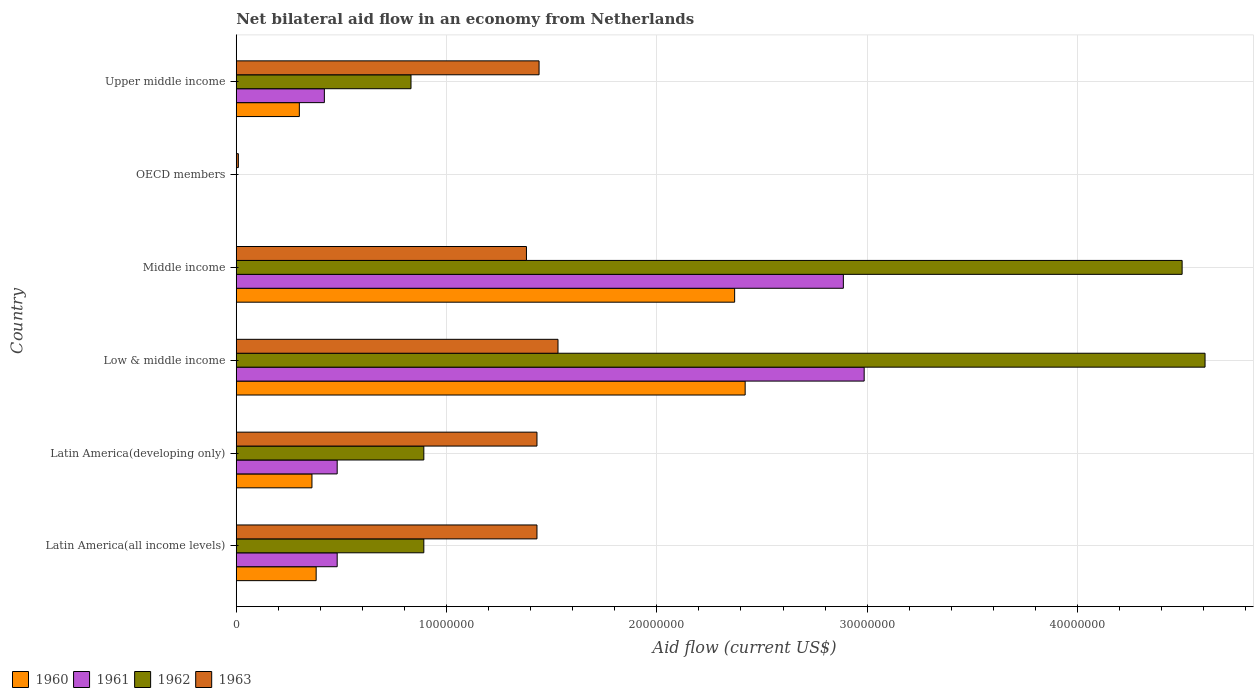How many bars are there on the 2nd tick from the bottom?
Your response must be concise. 4. What is the label of the 3rd group of bars from the top?
Offer a very short reply. Middle income. In how many cases, is the number of bars for a given country not equal to the number of legend labels?
Your response must be concise. 1. What is the net bilateral aid flow in 1963 in OECD members?
Keep it short and to the point. 1.00e+05. Across all countries, what is the maximum net bilateral aid flow in 1963?
Make the answer very short. 1.53e+07. In which country was the net bilateral aid flow in 1960 maximum?
Give a very brief answer. Low & middle income. What is the total net bilateral aid flow in 1960 in the graph?
Offer a terse response. 5.83e+07. What is the difference between the net bilateral aid flow in 1963 in Low & middle income and that in Middle income?
Provide a short and direct response. 1.50e+06. What is the difference between the net bilateral aid flow in 1960 in OECD members and the net bilateral aid flow in 1961 in Middle income?
Provide a succinct answer. -2.89e+07. What is the average net bilateral aid flow in 1963 per country?
Keep it short and to the point. 1.20e+07. What is the difference between the net bilateral aid flow in 1961 and net bilateral aid flow in 1960 in Latin America(developing only)?
Make the answer very short. 1.20e+06. In how many countries, is the net bilateral aid flow in 1961 greater than 42000000 US$?
Your answer should be very brief. 0. What is the ratio of the net bilateral aid flow in 1960 in Low & middle income to that in Middle income?
Make the answer very short. 1.02. Is the net bilateral aid flow in 1963 in Latin America(all income levels) less than that in Upper middle income?
Offer a very short reply. Yes. Is the difference between the net bilateral aid flow in 1961 in Middle income and Upper middle income greater than the difference between the net bilateral aid flow in 1960 in Middle income and Upper middle income?
Offer a terse response. Yes. What is the difference between the highest and the lowest net bilateral aid flow in 1962?
Give a very brief answer. 4.61e+07. Is the sum of the net bilateral aid flow in 1960 in Low & middle income and Upper middle income greater than the maximum net bilateral aid flow in 1963 across all countries?
Provide a short and direct response. Yes. Is it the case that in every country, the sum of the net bilateral aid flow in 1961 and net bilateral aid flow in 1963 is greater than the sum of net bilateral aid flow in 1962 and net bilateral aid flow in 1960?
Keep it short and to the point. No. Is it the case that in every country, the sum of the net bilateral aid flow in 1960 and net bilateral aid flow in 1963 is greater than the net bilateral aid flow in 1961?
Keep it short and to the point. Yes. What is the difference between two consecutive major ticks on the X-axis?
Your answer should be compact. 1.00e+07. Does the graph contain grids?
Keep it short and to the point. Yes. Where does the legend appear in the graph?
Provide a succinct answer. Bottom left. What is the title of the graph?
Your answer should be compact. Net bilateral aid flow in an economy from Netherlands. Does "1968" appear as one of the legend labels in the graph?
Offer a very short reply. No. What is the label or title of the X-axis?
Provide a short and direct response. Aid flow (current US$). What is the Aid flow (current US$) of 1960 in Latin America(all income levels)?
Ensure brevity in your answer.  3.80e+06. What is the Aid flow (current US$) in 1961 in Latin America(all income levels)?
Offer a very short reply. 4.80e+06. What is the Aid flow (current US$) in 1962 in Latin America(all income levels)?
Offer a very short reply. 8.92e+06. What is the Aid flow (current US$) in 1963 in Latin America(all income levels)?
Your answer should be compact. 1.43e+07. What is the Aid flow (current US$) in 1960 in Latin America(developing only)?
Keep it short and to the point. 3.60e+06. What is the Aid flow (current US$) of 1961 in Latin America(developing only)?
Provide a succinct answer. 4.80e+06. What is the Aid flow (current US$) of 1962 in Latin America(developing only)?
Offer a terse response. 8.92e+06. What is the Aid flow (current US$) of 1963 in Latin America(developing only)?
Provide a short and direct response. 1.43e+07. What is the Aid flow (current US$) of 1960 in Low & middle income?
Provide a succinct answer. 2.42e+07. What is the Aid flow (current US$) of 1961 in Low & middle income?
Make the answer very short. 2.99e+07. What is the Aid flow (current US$) of 1962 in Low & middle income?
Your answer should be very brief. 4.61e+07. What is the Aid flow (current US$) in 1963 in Low & middle income?
Your response must be concise. 1.53e+07. What is the Aid flow (current US$) in 1960 in Middle income?
Give a very brief answer. 2.37e+07. What is the Aid flow (current US$) of 1961 in Middle income?
Give a very brief answer. 2.89e+07. What is the Aid flow (current US$) in 1962 in Middle income?
Offer a very short reply. 4.50e+07. What is the Aid flow (current US$) of 1963 in Middle income?
Offer a very short reply. 1.38e+07. What is the Aid flow (current US$) of 1960 in OECD members?
Ensure brevity in your answer.  0. What is the Aid flow (current US$) in 1961 in OECD members?
Your answer should be very brief. 0. What is the Aid flow (current US$) of 1960 in Upper middle income?
Provide a succinct answer. 3.00e+06. What is the Aid flow (current US$) in 1961 in Upper middle income?
Your response must be concise. 4.19e+06. What is the Aid flow (current US$) of 1962 in Upper middle income?
Keep it short and to the point. 8.31e+06. What is the Aid flow (current US$) of 1963 in Upper middle income?
Make the answer very short. 1.44e+07. Across all countries, what is the maximum Aid flow (current US$) of 1960?
Offer a terse response. 2.42e+07. Across all countries, what is the maximum Aid flow (current US$) of 1961?
Your response must be concise. 2.99e+07. Across all countries, what is the maximum Aid flow (current US$) in 1962?
Keep it short and to the point. 4.61e+07. Across all countries, what is the maximum Aid flow (current US$) of 1963?
Your answer should be very brief. 1.53e+07. Across all countries, what is the minimum Aid flow (current US$) of 1962?
Your answer should be very brief. 0. What is the total Aid flow (current US$) in 1960 in the graph?
Offer a terse response. 5.83e+07. What is the total Aid flow (current US$) of 1961 in the graph?
Your answer should be compact. 7.25e+07. What is the total Aid flow (current US$) in 1962 in the graph?
Your answer should be compact. 1.17e+08. What is the total Aid flow (current US$) of 1963 in the graph?
Ensure brevity in your answer.  7.22e+07. What is the difference between the Aid flow (current US$) in 1962 in Latin America(all income levels) and that in Latin America(developing only)?
Give a very brief answer. 0. What is the difference between the Aid flow (current US$) of 1963 in Latin America(all income levels) and that in Latin America(developing only)?
Keep it short and to the point. 0. What is the difference between the Aid flow (current US$) in 1960 in Latin America(all income levels) and that in Low & middle income?
Offer a terse response. -2.04e+07. What is the difference between the Aid flow (current US$) of 1961 in Latin America(all income levels) and that in Low & middle income?
Make the answer very short. -2.51e+07. What is the difference between the Aid flow (current US$) in 1962 in Latin America(all income levels) and that in Low & middle income?
Offer a very short reply. -3.72e+07. What is the difference between the Aid flow (current US$) of 1960 in Latin America(all income levels) and that in Middle income?
Keep it short and to the point. -1.99e+07. What is the difference between the Aid flow (current US$) of 1961 in Latin America(all income levels) and that in Middle income?
Provide a short and direct response. -2.41e+07. What is the difference between the Aid flow (current US$) of 1962 in Latin America(all income levels) and that in Middle income?
Provide a succinct answer. -3.61e+07. What is the difference between the Aid flow (current US$) in 1963 in Latin America(all income levels) and that in OECD members?
Offer a terse response. 1.42e+07. What is the difference between the Aid flow (current US$) of 1960 in Latin America(all income levels) and that in Upper middle income?
Your response must be concise. 8.00e+05. What is the difference between the Aid flow (current US$) of 1961 in Latin America(all income levels) and that in Upper middle income?
Give a very brief answer. 6.10e+05. What is the difference between the Aid flow (current US$) of 1962 in Latin America(all income levels) and that in Upper middle income?
Your response must be concise. 6.10e+05. What is the difference between the Aid flow (current US$) in 1960 in Latin America(developing only) and that in Low & middle income?
Keep it short and to the point. -2.06e+07. What is the difference between the Aid flow (current US$) in 1961 in Latin America(developing only) and that in Low & middle income?
Provide a succinct answer. -2.51e+07. What is the difference between the Aid flow (current US$) in 1962 in Latin America(developing only) and that in Low & middle income?
Ensure brevity in your answer.  -3.72e+07. What is the difference between the Aid flow (current US$) of 1963 in Latin America(developing only) and that in Low & middle income?
Keep it short and to the point. -1.00e+06. What is the difference between the Aid flow (current US$) in 1960 in Latin America(developing only) and that in Middle income?
Your answer should be compact. -2.01e+07. What is the difference between the Aid flow (current US$) in 1961 in Latin America(developing only) and that in Middle income?
Your answer should be compact. -2.41e+07. What is the difference between the Aid flow (current US$) in 1962 in Latin America(developing only) and that in Middle income?
Offer a very short reply. -3.61e+07. What is the difference between the Aid flow (current US$) of 1963 in Latin America(developing only) and that in Middle income?
Offer a terse response. 5.00e+05. What is the difference between the Aid flow (current US$) of 1963 in Latin America(developing only) and that in OECD members?
Provide a succinct answer. 1.42e+07. What is the difference between the Aid flow (current US$) in 1961 in Low & middle income and that in Middle income?
Your answer should be very brief. 9.90e+05. What is the difference between the Aid flow (current US$) of 1962 in Low & middle income and that in Middle income?
Ensure brevity in your answer.  1.09e+06. What is the difference between the Aid flow (current US$) of 1963 in Low & middle income and that in Middle income?
Make the answer very short. 1.50e+06. What is the difference between the Aid flow (current US$) in 1963 in Low & middle income and that in OECD members?
Your answer should be compact. 1.52e+07. What is the difference between the Aid flow (current US$) of 1960 in Low & middle income and that in Upper middle income?
Your response must be concise. 2.12e+07. What is the difference between the Aid flow (current US$) of 1961 in Low & middle income and that in Upper middle income?
Offer a very short reply. 2.57e+07. What is the difference between the Aid flow (current US$) in 1962 in Low & middle income and that in Upper middle income?
Give a very brief answer. 3.78e+07. What is the difference between the Aid flow (current US$) of 1963 in Low & middle income and that in Upper middle income?
Ensure brevity in your answer.  9.00e+05. What is the difference between the Aid flow (current US$) in 1963 in Middle income and that in OECD members?
Give a very brief answer. 1.37e+07. What is the difference between the Aid flow (current US$) of 1960 in Middle income and that in Upper middle income?
Make the answer very short. 2.07e+07. What is the difference between the Aid flow (current US$) in 1961 in Middle income and that in Upper middle income?
Offer a very short reply. 2.47e+07. What is the difference between the Aid flow (current US$) of 1962 in Middle income and that in Upper middle income?
Your answer should be compact. 3.67e+07. What is the difference between the Aid flow (current US$) in 1963 in Middle income and that in Upper middle income?
Offer a terse response. -6.00e+05. What is the difference between the Aid flow (current US$) in 1963 in OECD members and that in Upper middle income?
Make the answer very short. -1.43e+07. What is the difference between the Aid flow (current US$) of 1960 in Latin America(all income levels) and the Aid flow (current US$) of 1961 in Latin America(developing only)?
Your answer should be very brief. -1.00e+06. What is the difference between the Aid flow (current US$) of 1960 in Latin America(all income levels) and the Aid flow (current US$) of 1962 in Latin America(developing only)?
Offer a very short reply. -5.12e+06. What is the difference between the Aid flow (current US$) of 1960 in Latin America(all income levels) and the Aid flow (current US$) of 1963 in Latin America(developing only)?
Ensure brevity in your answer.  -1.05e+07. What is the difference between the Aid flow (current US$) of 1961 in Latin America(all income levels) and the Aid flow (current US$) of 1962 in Latin America(developing only)?
Keep it short and to the point. -4.12e+06. What is the difference between the Aid flow (current US$) in 1961 in Latin America(all income levels) and the Aid flow (current US$) in 1963 in Latin America(developing only)?
Keep it short and to the point. -9.50e+06. What is the difference between the Aid flow (current US$) in 1962 in Latin America(all income levels) and the Aid flow (current US$) in 1963 in Latin America(developing only)?
Keep it short and to the point. -5.38e+06. What is the difference between the Aid flow (current US$) of 1960 in Latin America(all income levels) and the Aid flow (current US$) of 1961 in Low & middle income?
Your response must be concise. -2.61e+07. What is the difference between the Aid flow (current US$) of 1960 in Latin America(all income levels) and the Aid flow (current US$) of 1962 in Low & middle income?
Your answer should be very brief. -4.23e+07. What is the difference between the Aid flow (current US$) in 1960 in Latin America(all income levels) and the Aid flow (current US$) in 1963 in Low & middle income?
Provide a succinct answer. -1.15e+07. What is the difference between the Aid flow (current US$) in 1961 in Latin America(all income levels) and the Aid flow (current US$) in 1962 in Low & middle income?
Your answer should be compact. -4.13e+07. What is the difference between the Aid flow (current US$) in 1961 in Latin America(all income levels) and the Aid flow (current US$) in 1963 in Low & middle income?
Give a very brief answer. -1.05e+07. What is the difference between the Aid flow (current US$) of 1962 in Latin America(all income levels) and the Aid flow (current US$) of 1963 in Low & middle income?
Give a very brief answer. -6.38e+06. What is the difference between the Aid flow (current US$) in 1960 in Latin America(all income levels) and the Aid flow (current US$) in 1961 in Middle income?
Offer a very short reply. -2.51e+07. What is the difference between the Aid flow (current US$) in 1960 in Latin America(all income levels) and the Aid flow (current US$) in 1962 in Middle income?
Provide a succinct answer. -4.12e+07. What is the difference between the Aid flow (current US$) in 1960 in Latin America(all income levels) and the Aid flow (current US$) in 1963 in Middle income?
Your response must be concise. -1.00e+07. What is the difference between the Aid flow (current US$) in 1961 in Latin America(all income levels) and the Aid flow (current US$) in 1962 in Middle income?
Ensure brevity in your answer.  -4.02e+07. What is the difference between the Aid flow (current US$) of 1961 in Latin America(all income levels) and the Aid flow (current US$) of 1963 in Middle income?
Your response must be concise. -9.00e+06. What is the difference between the Aid flow (current US$) in 1962 in Latin America(all income levels) and the Aid flow (current US$) in 1963 in Middle income?
Offer a terse response. -4.88e+06. What is the difference between the Aid flow (current US$) of 1960 in Latin America(all income levels) and the Aid flow (current US$) of 1963 in OECD members?
Give a very brief answer. 3.70e+06. What is the difference between the Aid flow (current US$) in 1961 in Latin America(all income levels) and the Aid flow (current US$) in 1963 in OECD members?
Provide a short and direct response. 4.70e+06. What is the difference between the Aid flow (current US$) of 1962 in Latin America(all income levels) and the Aid flow (current US$) of 1963 in OECD members?
Provide a succinct answer. 8.82e+06. What is the difference between the Aid flow (current US$) of 1960 in Latin America(all income levels) and the Aid flow (current US$) of 1961 in Upper middle income?
Provide a short and direct response. -3.90e+05. What is the difference between the Aid flow (current US$) of 1960 in Latin America(all income levels) and the Aid flow (current US$) of 1962 in Upper middle income?
Your answer should be very brief. -4.51e+06. What is the difference between the Aid flow (current US$) in 1960 in Latin America(all income levels) and the Aid flow (current US$) in 1963 in Upper middle income?
Your response must be concise. -1.06e+07. What is the difference between the Aid flow (current US$) in 1961 in Latin America(all income levels) and the Aid flow (current US$) in 1962 in Upper middle income?
Provide a succinct answer. -3.51e+06. What is the difference between the Aid flow (current US$) in 1961 in Latin America(all income levels) and the Aid flow (current US$) in 1963 in Upper middle income?
Offer a terse response. -9.60e+06. What is the difference between the Aid flow (current US$) of 1962 in Latin America(all income levels) and the Aid flow (current US$) of 1963 in Upper middle income?
Offer a very short reply. -5.48e+06. What is the difference between the Aid flow (current US$) of 1960 in Latin America(developing only) and the Aid flow (current US$) of 1961 in Low & middle income?
Your answer should be compact. -2.63e+07. What is the difference between the Aid flow (current US$) in 1960 in Latin America(developing only) and the Aid flow (current US$) in 1962 in Low & middle income?
Your answer should be compact. -4.25e+07. What is the difference between the Aid flow (current US$) of 1960 in Latin America(developing only) and the Aid flow (current US$) of 1963 in Low & middle income?
Give a very brief answer. -1.17e+07. What is the difference between the Aid flow (current US$) of 1961 in Latin America(developing only) and the Aid flow (current US$) of 1962 in Low & middle income?
Your answer should be very brief. -4.13e+07. What is the difference between the Aid flow (current US$) of 1961 in Latin America(developing only) and the Aid flow (current US$) of 1963 in Low & middle income?
Give a very brief answer. -1.05e+07. What is the difference between the Aid flow (current US$) in 1962 in Latin America(developing only) and the Aid flow (current US$) in 1963 in Low & middle income?
Your response must be concise. -6.38e+06. What is the difference between the Aid flow (current US$) of 1960 in Latin America(developing only) and the Aid flow (current US$) of 1961 in Middle income?
Ensure brevity in your answer.  -2.53e+07. What is the difference between the Aid flow (current US$) in 1960 in Latin America(developing only) and the Aid flow (current US$) in 1962 in Middle income?
Offer a terse response. -4.14e+07. What is the difference between the Aid flow (current US$) of 1960 in Latin America(developing only) and the Aid flow (current US$) of 1963 in Middle income?
Give a very brief answer. -1.02e+07. What is the difference between the Aid flow (current US$) of 1961 in Latin America(developing only) and the Aid flow (current US$) of 1962 in Middle income?
Ensure brevity in your answer.  -4.02e+07. What is the difference between the Aid flow (current US$) of 1961 in Latin America(developing only) and the Aid flow (current US$) of 1963 in Middle income?
Your answer should be compact. -9.00e+06. What is the difference between the Aid flow (current US$) of 1962 in Latin America(developing only) and the Aid flow (current US$) of 1963 in Middle income?
Offer a terse response. -4.88e+06. What is the difference between the Aid flow (current US$) in 1960 in Latin America(developing only) and the Aid flow (current US$) in 1963 in OECD members?
Provide a short and direct response. 3.50e+06. What is the difference between the Aid flow (current US$) of 1961 in Latin America(developing only) and the Aid flow (current US$) of 1963 in OECD members?
Your answer should be compact. 4.70e+06. What is the difference between the Aid flow (current US$) of 1962 in Latin America(developing only) and the Aid flow (current US$) of 1963 in OECD members?
Give a very brief answer. 8.82e+06. What is the difference between the Aid flow (current US$) of 1960 in Latin America(developing only) and the Aid flow (current US$) of 1961 in Upper middle income?
Your response must be concise. -5.90e+05. What is the difference between the Aid flow (current US$) of 1960 in Latin America(developing only) and the Aid flow (current US$) of 1962 in Upper middle income?
Offer a very short reply. -4.71e+06. What is the difference between the Aid flow (current US$) in 1960 in Latin America(developing only) and the Aid flow (current US$) in 1963 in Upper middle income?
Provide a short and direct response. -1.08e+07. What is the difference between the Aid flow (current US$) of 1961 in Latin America(developing only) and the Aid flow (current US$) of 1962 in Upper middle income?
Provide a succinct answer. -3.51e+06. What is the difference between the Aid flow (current US$) in 1961 in Latin America(developing only) and the Aid flow (current US$) in 1963 in Upper middle income?
Provide a short and direct response. -9.60e+06. What is the difference between the Aid flow (current US$) in 1962 in Latin America(developing only) and the Aid flow (current US$) in 1963 in Upper middle income?
Make the answer very short. -5.48e+06. What is the difference between the Aid flow (current US$) in 1960 in Low & middle income and the Aid flow (current US$) in 1961 in Middle income?
Provide a succinct answer. -4.67e+06. What is the difference between the Aid flow (current US$) in 1960 in Low & middle income and the Aid flow (current US$) in 1962 in Middle income?
Give a very brief answer. -2.08e+07. What is the difference between the Aid flow (current US$) in 1960 in Low & middle income and the Aid flow (current US$) in 1963 in Middle income?
Your answer should be compact. 1.04e+07. What is the difference between the Aid flow (current US$) in 1961 in Low & middle income and the Aid flow (current US$) in 1962 in Middle income?
Provide a short and direct response. -1.51e+07. What is the difference between the Aid flow (current US$) of 1961 in Low & middle income and the Aid flow (current US$) of 1963 in Middle income?
Provide a succinct answer. 1.61e+07. What is the difference between the Aid flow (current US$) in 1962 in Low & middle income and the Aid flow (current US$) in 1963 in Middle income?
Provide a short and direct response. 3.23e+07. What is the difference between the Aid flow (current US$) in 1960 in Low & middle income and the Aid flow (current US$) in 1963 in OECD members?
Your answer should be compact. 2.41e+07. What is the difference between the Aid flow (current US$) in 1961 in Low & middle income and the Aid flow (current US$) in 1963 in OECD members?
Your answer should be compact. 2.98e+07. What is the difference between the Aid flow (current US$) of 1962 in Low & middle income and the Aid flow (current US$) of 1963 in OECD members?
Provide a succinct answer. 4.60e+07. What is the difference between the Aid flow (current US$) of 1960 in Low & middle income and the Aid flow (current US$) of 1961 in Upper middle income?
Ensure brevity in your answer.  2.00e+07. What is the difference between the Aid flow (current US$) in 1960 in Low & middle income and the Aid flow (current US$) in 1962 in Upper middle income?
Ensure brevity in your answer.  1.59e+07. What is the difference between the Aid flow (current US$) of 1960 in Low & middle income and the Aid flow (current US$) of 1963 in Upper middle income?
Make the answer very short. 9.80e+06. What is the difference between the Aid flow (current US$) of 1961 in Low & middle income and the Aid flow (current US$) of 1962 in Upper middle income?
Offer a very short reply. 2.16e+07. What is the difference between the Aid flow (current US$) of 1961 in Low & middle income and the Aid flow (current US$) of 1963 in Upper middle income?
Make the answer very short. 1.55e+07. What is the difference between the Aid flow (current US$) of 1962 in Low & middle income and the Aid flow (current US$) of 1963 in Upper middle income?
Your answer should be very brief. 3.17e+07. What is the difference between the Aid flow (current US$) in 1960 in Middle income and the Aid flow (current US$) in 1963 in OECD members?
Offer a terse response. 2.36e+07. What is the difference between the Aid flow (current US$) of 1961 in Middle income and the Aid flow (current US$) of 1963 in OECD members?
Offer a very short reply. 2.88e+07. What is the difference between the Aid flow (current US$) in 1962 in Middle income and the Aid flow (current US$) in 1963 in OECD members?
Provide a short and direct response. 4.49e+07. What is the difference between the Aid flow (current US$) of 1960 in Middle income and the Aid flow (current US$) of 1961 in Upper middle income?
Make the answer very short. 1.95e+07. What is the difference between the Aid flow (current US$) of 1960 in Middle income and the Aid flow (current US$) of 1962 in Upper middle income?
Offer a very short reply. 1.54e+07. What is the difference between the Aid flow (current US$) of 1960 in Middle income and the Aid flow (current US$) of 1963 in Upper middle income?
Offer a terse response. 9.30e+06. What is the difference between the Aid flow (current US$) in 1961 in Middle income and the Aid flow (current US$) in 1962 in Upper middle income?
Make the answer very short. 2.06e+07. What is the difference between the Aid flow (current US$) in 1961 in Middle income and the Aid flow (current US$) in 1963 in Upper middle income?
Your answer should be very brief. 1.45e+07. What is the difference between the Aid flow (current US$) of 1962 in Middle income and the Aid flow (current US$) of 1963 in Upper middle income?
Provide a succinct answer. 3.06e+07. What is the average Aid flow (current US$) in 1960 per country?
Ensure brevity in your answer.  9.72e+06. What is the average Aid flow (current US$) in 1961 per country?
Provide a short and direct response. 1.21e+07. What is the average Aid flow (current US$) in 1962 per country?
Your response must be concise. 1.95e+07. What is the average Aid flow (current US$) of 1963 per country?
Make the answer very short. 1.20e+07. What is the difference between the Aid flow (current US$) in 1960 and Aid flow (current US$) in 1962 in Latin America(all income levels)?
Offer a terse response. -5.12e+06. What is the difference between the Aid flow (current US$) of 1960 and Aid flow (current US$) of 1963 in Latin America(all income levels)?
Ensure brevity in your answer.  -1.05e+07. What is the difference between the Aid flow (current US$) in 1961 and Aid flow (current US$) in 1962 in Latin America(all income levels)?
Provide a short and direct response. -4.12e+06. What is the difference between the Aid flow (current US$) of 1961 and Aid flow (current US$) of 1963 in Latin America(all income levels)?
Make the answer very short. -9.50e+06. What is the difference between the Aid flow (current US$) in 1962 and Aid flow (current US$) in 1963 in Latin America(all income levels)?
Ensure brevity in your answer.  -5.38e+06. What is the difference between the Aid flow (current US$) in 1960 and Aid flow (current US$) in 1961 in Latin America(developing only)?
Provide a succinct answer. -1.20e+06. What is the difference between the Aid flow (current US$) of 1960 and Aid flow (current US$) of 1962 in Latin America(developing only)?
Keep it short and to the point. -5.32e+06. What is the difference between the Aid flow (current US$) in 1960 and Aid flow (current US$) in 1963 in Latin America(developing only)?
Give a very brief answer. -1.07e+07. What is the difference between the Aid flow (current US$) of 1961 and Aid flow (current US$) of 1962 in Latin America(developing only)?
Your response must be concise. -4.12e+06. What is the difference between the Aid flow (current US$) of 1961 and Aid flow (current US$) of 1963 in Latin America(developing only)?
Offer a very short reply. -9.50e+06. What is the difference between the Aid flow (current US$) of 1962 and Aid flow (current US$) of 1963 in Latin America(developing only)?
Your answer should be very brief. -5.38e+06. What is the difference between the Aid flow (current US$) in 1960 and Aid flow (current US$) in 1961 in Low & middle income?
Offer a very short reply. -5.66e+06. What is the difference between the Aid flow (current US$) of 1960 and Aid flow (current US$) of 1962 in Low & middle income?
Keep it short and to the point. -2.19e+07. What is the difference between the Aid flow (current US$) of 1960 and Aid flow (current US$) of 1963 in Low & middle income?
Make the answer very short. 8.90e+06. What is the difference between the Aid flow (current US$) of 1961 and Aid flow (current US$) of 1962 in Low & middle income?
Give a very brief answer. -1.62e+07. What is the difference between the Aid flow (current US$) of 1961 and Aid flow (current US$) of 1963 in Low & middle income?
Offer a very short reply. 1.46e+07. What is the difference between the Aid flow (current US$) in 1962 and Aid flow (current US$) in 1963 in Low & middle income?
Provide a succinct answer. 3.08e+07. What is the difference between the Aid flow (current US$) of 1960 and Aid flow (current US$) of 1961 in Middle income?
Make the answer very short. -5.17e+06. What is the difference between the Aid flow (current US$) of 1960 and Aid flow (current US$) of 1962 in Middle income?
Provide a short and direct response. -2.13e+07. What is the difference between the Aid flow (current US$) in 1960 and Aid flow (current US$) in 1963 in Middle income?
Offer a very short reply. 9.90e+06. What is the difference between the Aid flow (current US$) in 1961 and Aid flow (current US$) in 1962 in Middle income?
Make the answer very short. -1.61e+07. What is the difference between the Aid flow (current US$) in 1961 and Aid flow (current US$) in 1963 in Middle income?
Ensure brevity in your answer.  1.51e+07. What is the difference between the Aid flow (current US$) of 1962 and Aid flow (current US$) of 1963 in Middle income?
Provide a succinct answer. 3.12e+07. What is the difference between the Aid flow (current US$) in 1960 and Aid flow (current US$) in 1961 in Upper middle income?
Provide a short and direct response. -1.19e+06. What is the difference between the Aid flow (current US$) of 1960 and Aid flow (current US$) of 1962 in Upper middle income?
Offer a terse response. -5.31e+06. What is the difference between the Aid flow (current US$) in 1960 and Aid flow (current US$) in 1963 in Upper middle income?
Provide a short and direct response. -1.14e+07. What is the difference between the Aid flow (current US$) in 1961 and Aid flow (current US$) in 1962 in Upper middle income?
Make the answer very short. -4.12e+06. What is the difference between the Aid flow (current US$) in 1961 and Aid flow (current US$) in 1963 in Upper middle income?
Offer a very short reply. -1.02e+07. What is the difference between the Aid flow (current US$) in 1962 and Aid flow (current US$) in 1963 in Upper middle income?
Provide a succinct answer. -6.09e+06. What is the ratio of the Aid flow (current US$) of 1960 in Latin America(all income levels) to that in Latin America(developing only)?
Your answer should be compact. 1.06. What is the ratio of the Aid flow (current US$) of 1961 in Latin America(all income levels) to that in Latin America(developing only)?
Make the answer very short. 1. What is the ratio of the Aid flow (current US$) in 1963 in Latin America(all income levels) to that in Latin America(developing only)?
Provide a short and direct response. 1. What is the ratio of the Aid flow (current US$) of 1960 in Latin America(all income levels) to that in Low & middle income?
Provide a succinct answer. 0.16. What is the ratio of the Aid flow (current US$) of 1961 in Latin America(all income levels) to that in Low & middle income?
Your response must be concise. 0.16. What is the ratio of the Aid flow (current US$) in 1962 in Latin America(all income levels) to that in Low & middle income?
Make the answer very short. 0.19. What is the ratio of the Aid flow (current US$) of 1963 in Latin America(all income levels) to that in Low & middle income?
Offer a very short reply. 0.93. What is the ratio of the Aid flow (current US$) in 1960 in Latin America(all income levels) to that in Middle income?
Your response must be concise. 0.16. What is the ratio of the Aid flow (current US$) of 1961 in Latin America(all income levels) to that in Middle income?
Provide a short and direct response. 0.17. What is the ratio of the Aid flow (current US$) in 1962 in Latin America(all income levels) to that in Middle income?
Provide a short and direct response. 0.2. What is the ratio of the Aid flow (current US$) of 1963 in Latin America(all income levels) to that in Middle income?
Offer a terse response. 1.04. What is the ratio of the Aid flow (current US$) of 1963 in Latin America(all income levels) to that in OECD members?
Your answer should be compact. 143. What is the ratio of the Aid flow (current US$) of 1960 in Latin America(all income levels) to that in Upper middle income?
Your answer should be compact. 1.27. What is the ratio of the Aid flow (current US$) of 1961 in Latin America(all income levels) to that in Upper middle income?
Provide a short and direct response. 1.15. What is the ratio of the Aid flow (current US$) in 1962 in Latin America(all income levels) to that in Upper middle income?
Provide a short and direct response. 1.07. What is the ratio of the Aid flow (current US$) of 1963 in Latin America(all income levels) to that in Upper middle income?
Your answer should be very brief. 0.99. What is the ratio of the Aid flow (current US$) in 1960 in Latin America(developing only) to that in Low & middle income?
Ensure brevity in your answer.  0.15. What is the ratio of the Aid flow (current US$) of 1961 in Latin America(developing only) to that in Low & middle income?
Give a very brief answer. 0.16. What is the ratio of the Aid flow (current US$) of 1962 in Latin America(developing only) to that in Low & middle income?
Give a very brief answer. 0.19. What is the ratio of the Aid flow (current US$) of 1963 in Latin America(developing only) to that in Low & middle income?
Your answer should be very brief. 0.93. What is the ratio of the Aid flow (current US$) in 1960 in Latin America(developing only) to that in Middle income?
Offer a very short reply. 0.15. What is the ratio of the Aid flow (current US$) of 1961 in Latin America(developing only) to that in Middle income?
Ensure brevity in your answer.  0.17. What is the ratio of the Aid flow (current US$) in 1962 in Latin America(developing only) to that in Middle income?
Provide a succinct answer. 0.2. What is the ratio of the Aid flow (current US$) of 1963 in Latin America(developing only) to that in Middle income?
Keep it short and to the point. 1.04. What is the ratio of the Aid flow (current US$) in 1963 in Latin America(developing only) to that in OECD members?
Provide a succinct answer. 143. What is the ratio of the Aid flow (current US$) of 1961 in Latin America(developing only) to that in Upper middle income?
Provide a succinct answer. 1.15. What is the ratio of the Aid flow (current US$) of 1962 in Latin America(developing only) to that in Upper middle income?
Make the answer very short. 1.07. What is the ratio of the Aid flow (current US$) of 1960 in Low & middle income to that in Middle income?
Provide a succinct answer. 1.02. What is the ratio of the Aid flow (current US$) of 1961 in Low & middle income to that in Middle income?
Ensure brevity in your answer.  1.03. What is the ratio of the Aid flow (current US$) of 1962 in Low & middle income to that in Middle income?
Your answer should be compact. 1.02. What is the ratio of the Aid flow (current US$) in 1963 in Low & middle income to that in Middle income?
Provide a succinct answer. 1.11. What is the ratio of the Aid flow (current US$) in 1963 in Low & middle income to that in OECD members?
Offer a terse response. 153. What is the ratio of the Aid flow (current US$) of 1960 in Low & middle income to that in Upper middle income?
Your answer should be very brief. 8.07. What is the ratio of the Aid flow (current US$) in 1961 in Low & middle income to that in Upper middle income?
Make the answer very short. 7.13. What is the ratio of the Aid flow (current US$) of 1962 in Low & middle income to that in Upper middle income?
Ensure brevity in your answer.  5.54. What is the ratio of the Aid flow (current US$) of 1963 in Middle income to that in OECD members?
Your answer should be compact. 138. What is the ratio of the Aid flow (current US$) in 1961 in Middle income to that in Upper middle income?
Your answer should be very brief. 6.89. What is the ratio of the Aid flow (current US$) in 1962 in Middle income to that in Upper middle income?
Your response must be concise. 5.41. What is the ratio of the Aid flow (current US$) in 1963 in OECD members to that in Upper middle income?
Offer a very short reply. 0.01. What is the difference between the highest and the second highest Aid flow (current US$) in 1960?
Keep it short and to the point. 5.00e+05. What is the difference between the highest and the second highest Aid flow (current US$) of 1961?
Give a very brief answer. 9.90e+05. What is the difference between the highest and the second highest Aid flow (current US$) in 1962?
Your response must be concise. 1.09e+06. What is the difference between the highest and the second highest Aid flow (current US$) in 1963?
Provide a succinct answer. 9.00e+05. What is the difference between the highest and the lowest Aid flow (current US$) of 1960?
Offer a terse response. 2.42e+07. What is the difference between the highest and the lowest Aid flow (current US$) in 1961?
Offer a terse response. 2.99e+07. What is the difference between the highest and the lowest Aid flow (current US$) in 1962?
Offer a terse response. 4.61e+07. What is the difference between the highest and the lowest Aid flow (current US$) of 1963?
Offer a very short reply. 1.52e+07. 